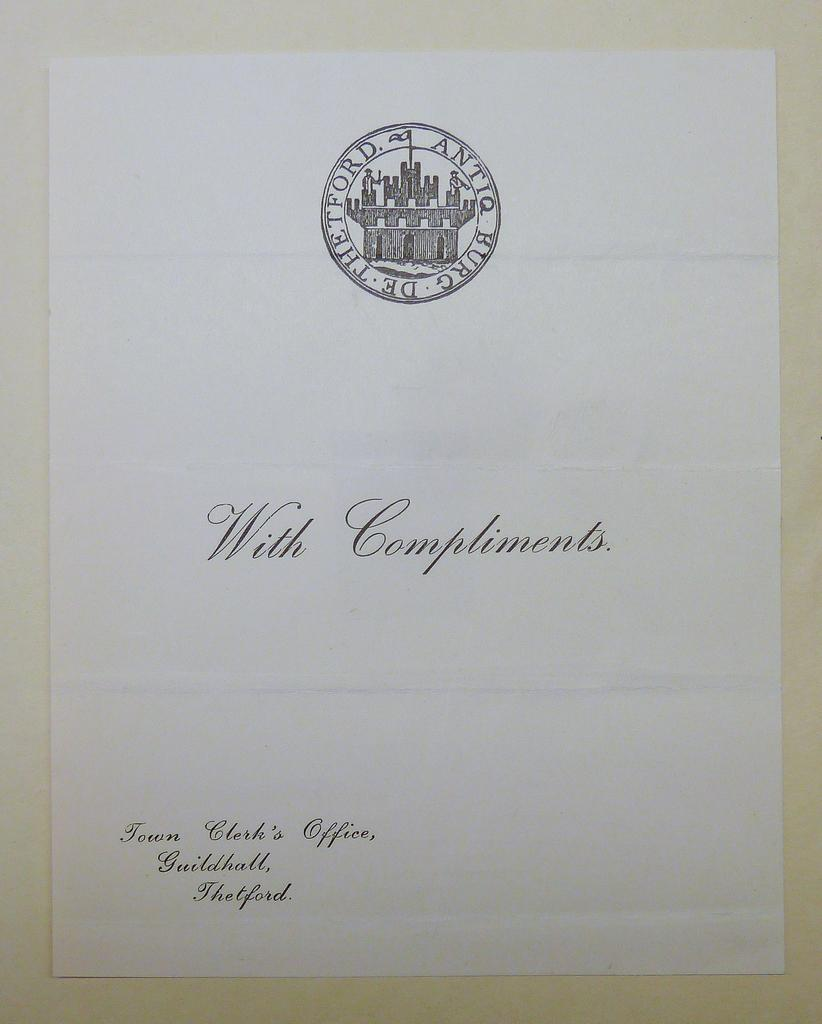What is present on the paper in the image? The paper has a stamp on it. What else can be seen on the paper? There is text written on the paper. What type of berry is depicted on the paper in the image? There is no berry depicted on the paper in the image. 